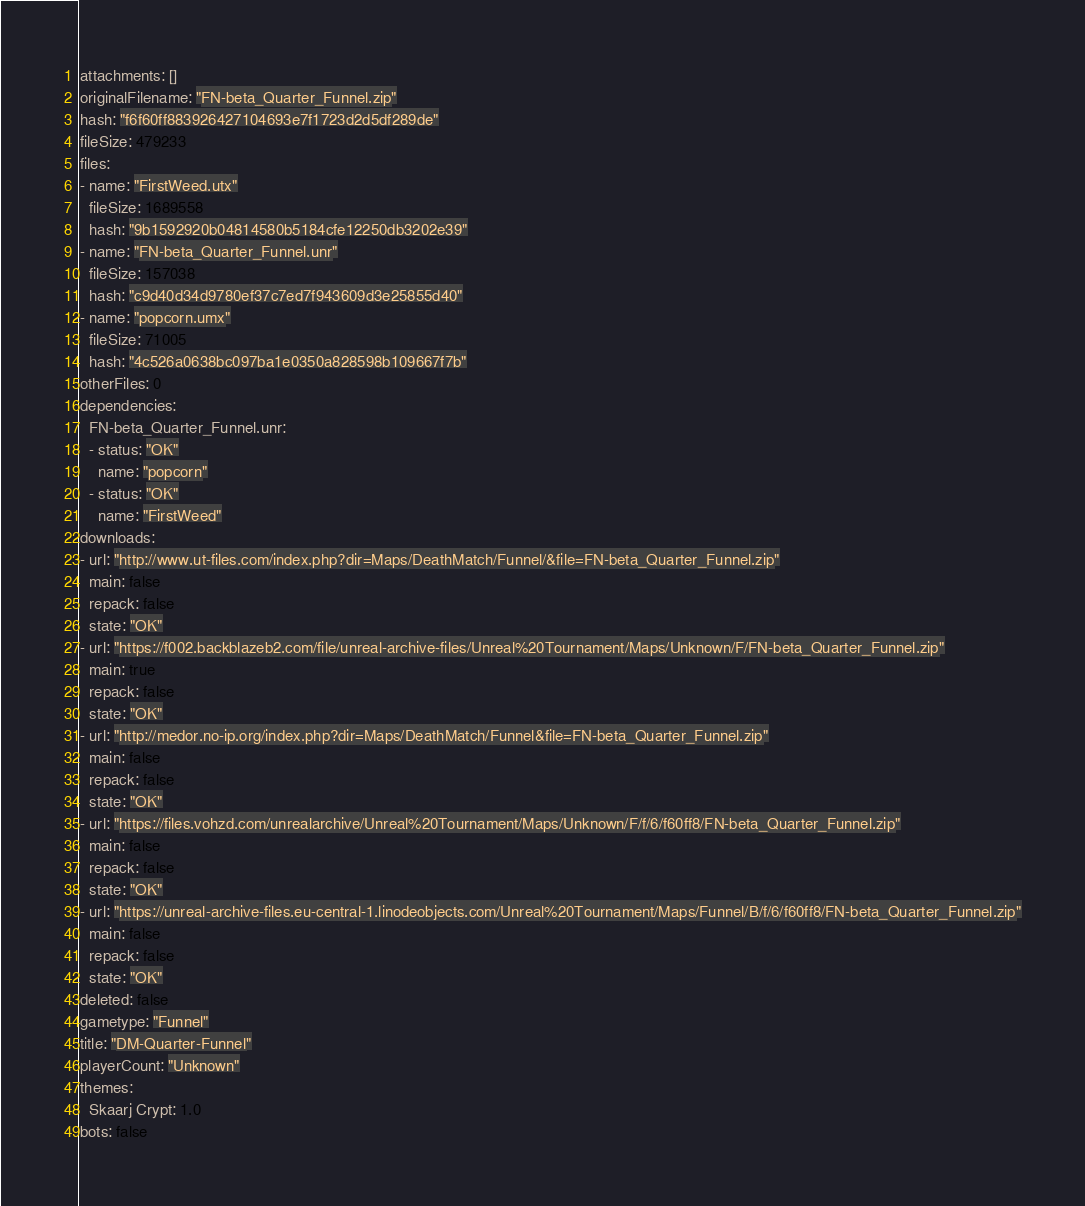Convert code to text. <code><loc_0><loc_0><loc_500><loc_500><_YAML_>attachments: []
originalFilename: "FN-beta_Quarter_Funnel.zip"
hash: "f6f60ff883926427104693e7f1723d2d5df289de"
fileSize: 479233
files:
- name: "FirstWeed.utx"
  fileSize: 1689558
  hash: "9b1592920b04814580b5184cfe12250db3202e39"
- name: "FN-beta_Quarter_Funnel.unr"
  fileSize: 157038
  hash: "c9d40d34d9780ef37c7ed7f943609d3e25855d40"
- name: "popcorn.umx"
  fileSize: 71005
  hash: "4c526a0638bc097ba1e0350a828598b109667f7b"
otherFiles: 0
dependencies:
  FN-beta_Quarter_Funnel.unr:
  - status: "OK"
    name: "popcorn"
  - status: "OK"
    name: "FirstWeed"
downloads:
- url: "http://www.ut-files.com/index.php?dir=Maps/DeathMatch/Funnel/&file=FN-beta_Quarter_Funnel.zip"
  main: false
  repack: false
  state: "OK"
- url: "https://f002.backblazeb2.com/file/unreal-archive-files/Unreal%20Tournament/Maps/Unknown/F/FN-beta_Quarter_Funnel.zip"
  main: true
  repack: false
  state: "OK"
- url: "http://medor.no-ip.org/index.php?dir=Maps/DeathMatch/Funnel&file=FN-beta_Quarter_Funnel.zip"
  main: false
  repack: false
  state: "OK"
- url: "https://files.vohzd.com/unrealarchive/Unreal%20Tournament/Maps/Unknown/F/f/6/f60ff8/FN-beta_Quarter_Funnel.zip"
  main: false
  repack: false
  state: "OK"
- url: "https://unreal-archive-files.eu-central-1.linodeobjects.com/Unreal%20Tournament/Maps/Funnel/B/f/6/f60ff8/FN-beta_Quarter_Funnel.zip"
  main: false
  repack: false
  state: "OK"
deleted: false
gametype: "Funnel"
title: "DM-Quarter-Funnel"
playerCount: "Unknown"
themes:
  Skaarj Crypt: 1.0
bots: false
</code> 